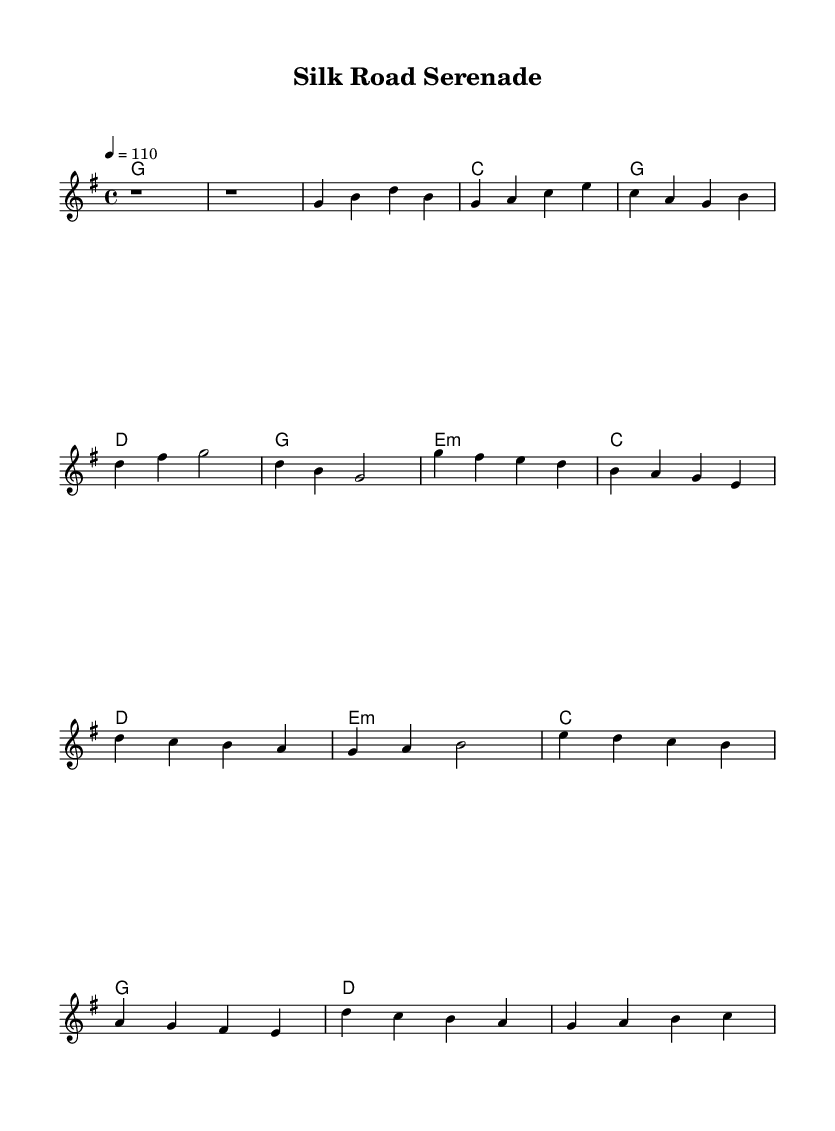What is the key signature of this music? The key signature is G major, indicated by one sharp (F#) in the music.
Answer: G major What is the time signature of this music? The time signature is 4/4, which means there are four beats in a measure.
Answer: 4/4 What is the tempo marking for this piece? The tempo marking indicates a speed of 110 beats per minute, shown as "4 = 110."
Answer: 110 How many measures are there in the verse section? The verse section consists of four measures, as observed in the melody part.
Answer: 4 What chord accompanies the chorus? The chorus features several chords, including G major, E minor, C major, and D major.
Answer: G major, E minor, C major, D major Which musical element indicates a bridge section? The bridge section is denoted by a change in melody and harmonies; it follows the chorus.
Answer: Bridge How does this piece reflect a blend of cultural influences? The piece uses traditional Western country rock elements, such as the chord progression, while potentially incorporating melodic or structural elements reminiscent of Asian music, thus showcasing a fusion of styles.
Answer: Fusion of styles 